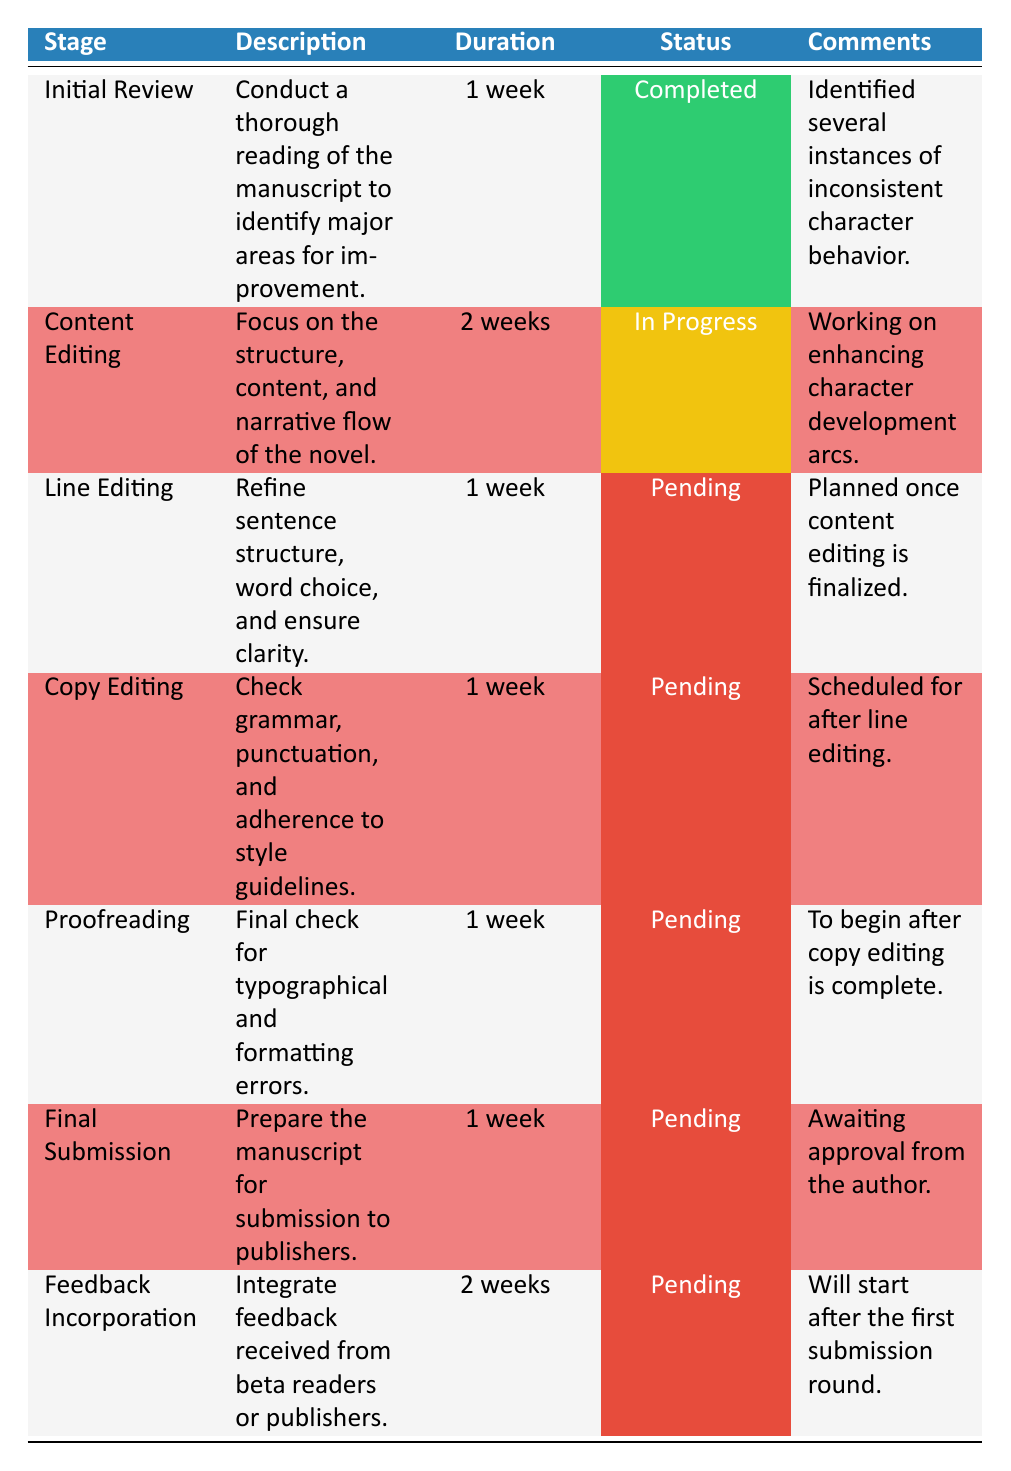What is the status of the Content Editing stage? The Content Editing stage is currently marked as "In Progress," which can be directly retrieved from the status column of that particular row in the table.
Answer: In Progress Which stage has been completed first in the workflow? The Initial Review stage is the first row in the table and is marked as "Completed." This indicates that it was finished before any other stages.
Answer: Initial Review How many total weeks is allocated for the Feedback Incorporation stage? The table shows that the Feedback Incorporation stage has a duration of "2 weeks," which can be found in the duration column of that specific row.
Answer: 2 weeks Is Line Editing scheduled to start before Copy Editing? Yes, the Line Editing stage is marked as "Pending" and is planned once the Content Editing is finalized. Copy Editing will occur after Line Editing, according to their respective comments.
Answer: Yes What is the total duration for all stages that are still pending? The pending stages are Line Editing, Copy Editing, Proofreading, Final Submission, and Feedback Incorporation, which sum up their durations: 1 week (Line Editing) + 1 week (Copy Editing) + 1 week (Proofreading) + 1 week (Final Submission) + 2 weeks (Feedback Incorporation) = 6 weeks total.
Answer: 6 weeks How many stages are currently either completed or in progress? The Initial Review stage is completed, and the Content Editing stage is in progress. Therefore, there are a total of two stages that fall under these categories when counted.
Answer: 2 stages What percentage of the stages have been completed or are in progress? There are 7 stages in total. With 1 completed and 1 in progress, that's 2 out of 7. To find the percentage, calculate (2/7) * 100, which equals approximately 28.57%.
Answer: Approximately 28.57% What is the average duration of all stages in the workflow? The stages durations are: 1 week (Initial Review), 2 weeks (Content Editing), 1 week (Line Editing), 1 week (Copy Editing), 1 week (Proofreading), 1 week (Final Submission), and 2 weeks (Feedback Incorporation), which totals 9 weeks. Dividing by 7 stages gives an average duration of 9/7, which is approximately 1.29 weeks.
Answer: Approximately 1.29 weeks Which stage has the longest duration and what is that duration? The only stage with a duration of 2 weeks is the Content Editing and Feedback Incorporation stages. To identify the longest single stage, we can refer to their respective durations in the table. Among them, they both equally have the longest duration of 2 weeks.
Answer: 2 weeks 